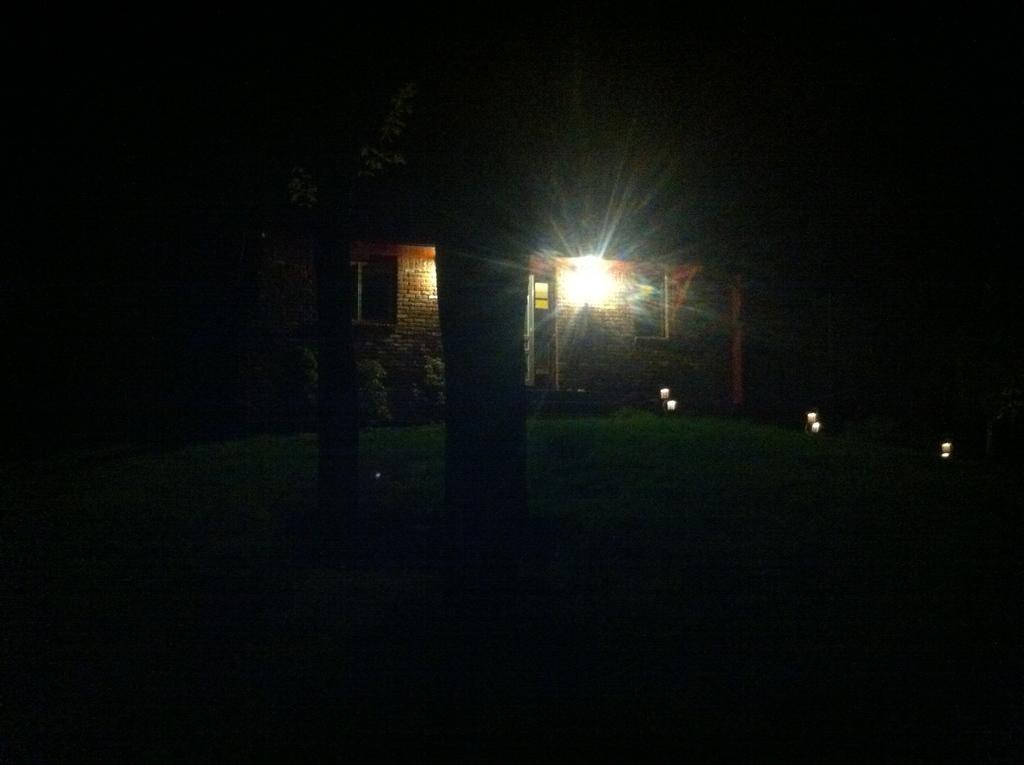Can you describe this image briefly? In this image I can see yellow colour building, a light, few plants, grass and I can see this image is in dark. 